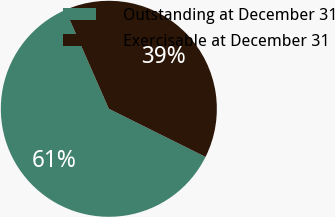Convert chart. <chart><loc_0><loc_0><loc_500><loc_500><pie_chart><fcel>Outstanding at December 31<fcel>Exercisable at December 31<nl><fcel>61.07%<fcel>38.93%<nl></chart> 